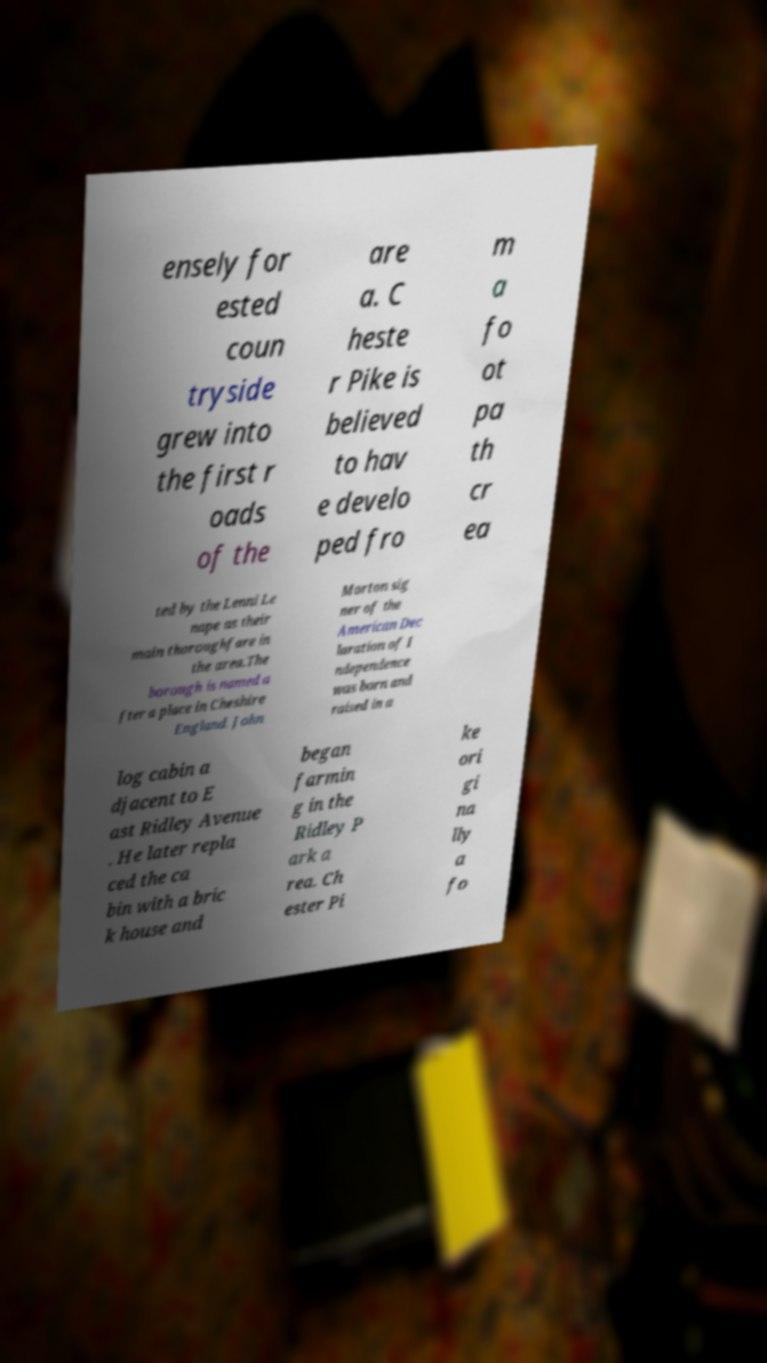For documentation purposes, I need the text within this image transcribed. Could you provide that? ensely for ested coun tryside grew into the first r oads of the are a. C heste r Pike is believed to hav e develo ped fro m a fo ot pa th cr ea ted by the Lenni Le nape as their main thoroughfare in the area.The borough is named a fter a place in Cheshire England. John Morton sig ner of the American Dec laration of I ndependence was born and raised in a log cabin a djacent to E ast Ridley Avenue . He later repla ced the ca bin with a bric k house and began farmin g in the Ridley P ark a rea. Ch ester Pi ke ori gi na lly a fo 